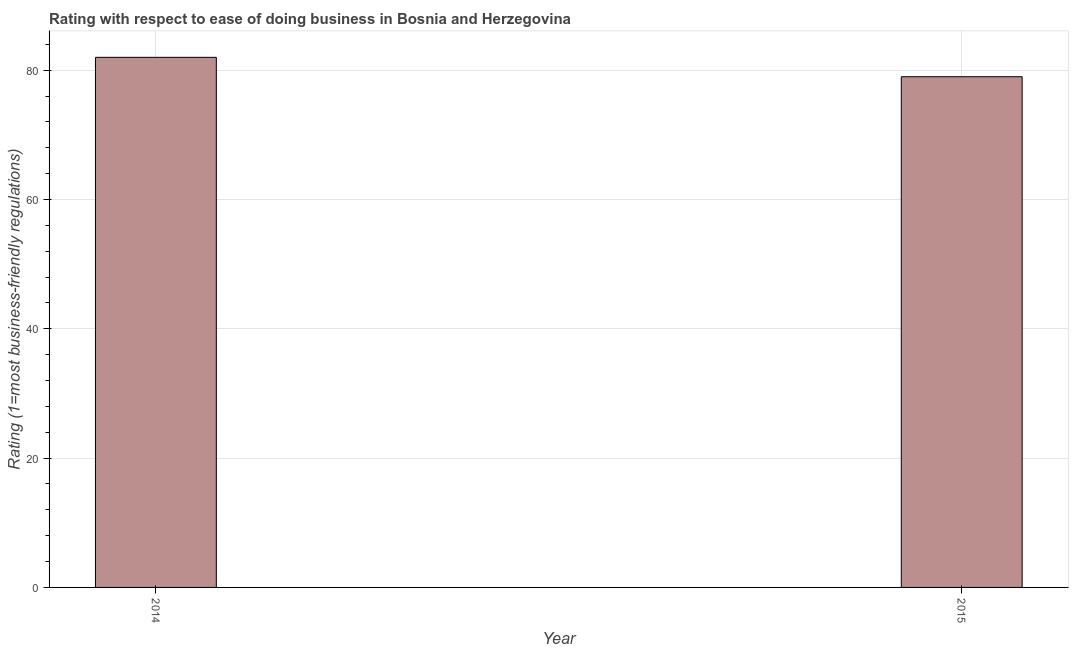Does the graph contain grids?
Keep it short and to the point. Yes. What is the title of the graph?
Ensure brevity in your answer.  Rating with respect to ease of doing business in Bosnia and Herzegovina. What is the label or title of the X-axis?
Provide a succinct answer. Year. What is the label or title of the Y-axis?
Provide a short and direct response. Rating (1=most business-friendly regulations). What is the ease of doing business index in 2015?
Ensure brevity in your answer.  79. Across all years, what is the maximum ease of doing business index?
Provide a succinct answer. 82. Across all years, what is the minimum ease of doing business index?
Keep it short and to the point. 79. In which year was the ease of doing business index minimum?
Offer a terse response. 2015. What is the sum of the ease of doing business index?
Make the answer very short. 161. What is the difference between the ease of doing business index in 2014 and 2015?
Provide a succinct answer. 3. What is the average ease of doing business index per year?
Provide a short and direct response. 80. What is the median ease of doing business index?
Provide a short and direct response. 80.5. What is the ratio of the ease of doing business index in 2014 to that in 2015?
Provide a succinct answer. 1.04. Is the ease of doing business index in 2014 less than that in 2015?
Your answer should be very brief. No. How many bars are there?
Offer a terse response. 2. What is the difference between two consecutive major ticks on the Y-axis?
Make the answer very short. 20. Are the values on the major ticks of Y-axis written in scientific E-notation?
Provide a succinct answer. No. What is the Rating (1=most business-friendly regulations) in 2015?
Provide a succinct answer. 79. What is the difference between the Rating (1=most business-friendly regulations) in 2014 and 2015?
Offer a very short reply. 3. What is the ratio of the Rating (1=most business-friendly regulations) in 2014 to that in 2015?
Your answer should be compact. 1.04. 